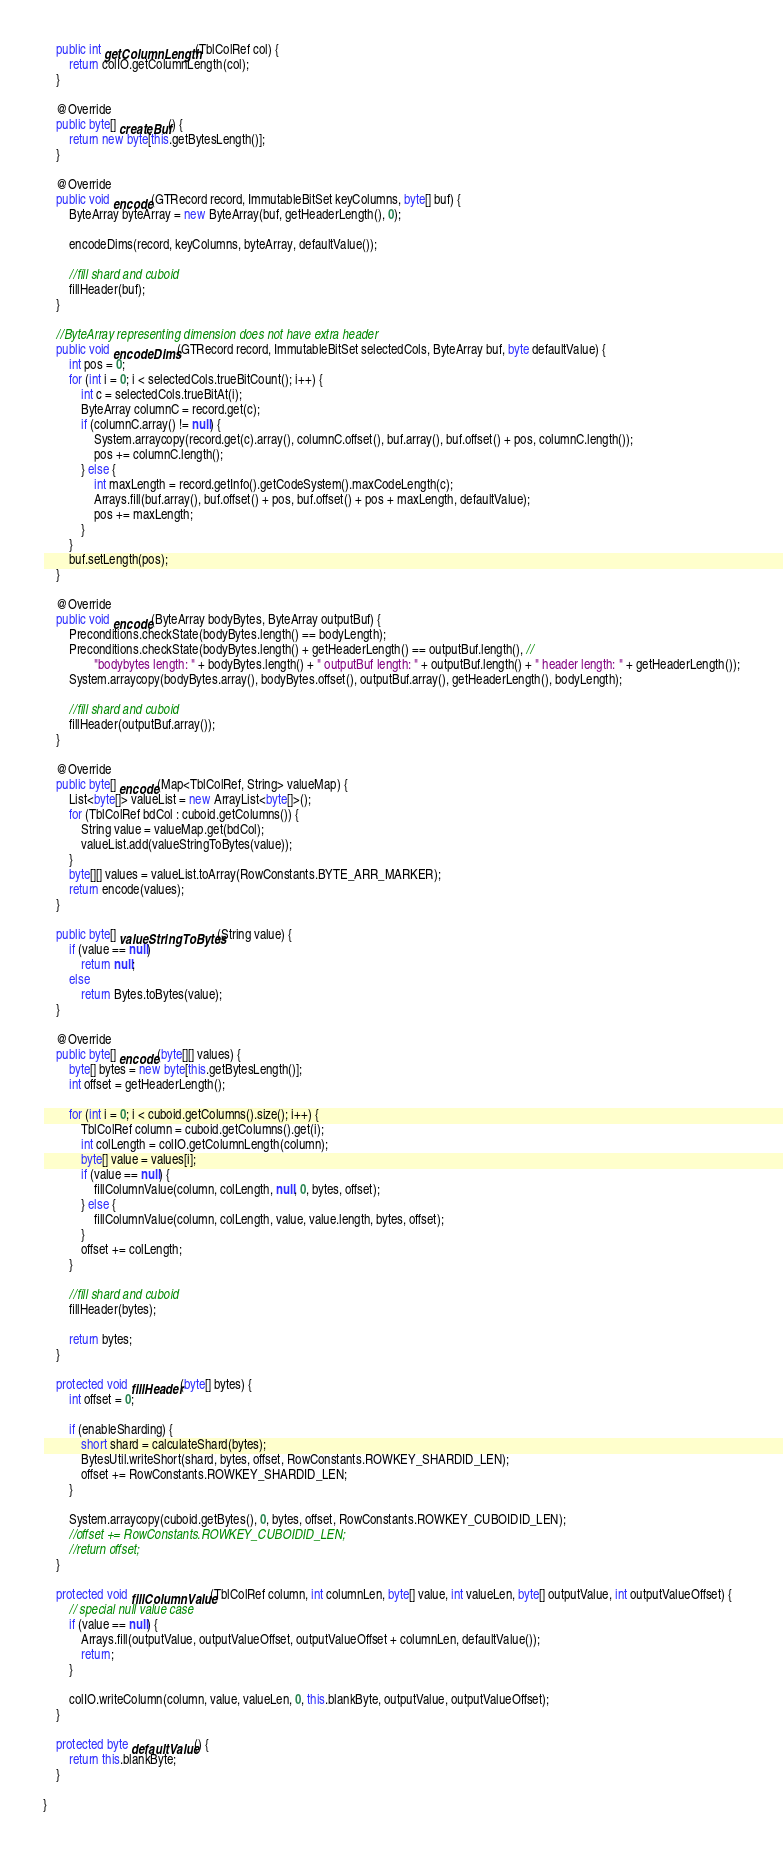<code> <loc_0><loc_0><loc_500><loc_500><_Java_>    public int getColumnLength(TblColRef col) {
        return colIO.getColumnLength(col);
    }

    @Override
    public byte[] createBuf() {
        return new byte[this.getBytesLength()];
    }

    @Override
    public void encode(GTRecord record, ImmutableBitSet keyColumns, byte[] buf) {
        ByteArray byteArray = new ByteArray(buf, getHeaderLength(), 0);

        encodeDims(record, keyColumns, byteArray, defaultValue());

        //fill shard and cuboid
        fillHeader(buf);
    }

    //ByteArray representing dimension does not have extra header
    public void encodeDims(GTRecord record, ImmutableBitSet selectedCols, ByteArray buf, byte defaultValue) {
        int pos = 0;
        for (int i = 0; i < selectedCols.trueBitCount(); i++) {
            int c = selectedCols.trueBitAt(i);
            ByteArray columnC = record.get(c);
            if (columnC.array() != null) {
                System.arraycopy(record.get(c).array(), columnC.offset(), buf.array(), buf.offset() + pos, columnC.length());
                pos += columnC.length();
            } else {
                int maxLength = record.getInfo().getCodeSystem().maxCodeLength(c);
                Arrays.fill(buf.array(), buf.offset() + pos, buf.offset() + pos + maxLength, defaultValue);
                pos += maxLength;
            }
        }
        buf.setLength(pos);
    }

    @Override
    public void encode(ByteArray bodyBytes, ByteArray outputBuf) {
        Preconditions.checkState(bodyBytes.length() == bodyLength);
        Preconditions.checkState(bodyBytes.length() + getHeaderLength() == outputBuf.length(), //
                "bodybytes length: " + bodyBytes.length() + " outputBuf length: " + outputBuf.length() + " header length: " + getHeaderLength());
        System.arraycopy(bodyBytes.array(), bodyBytes.offset(), outputBuf.array(), getHeaderLength(), bodyLength);

        //fill shard and cuboid
        fillHeader(outputBuf.array());
    }

    @Override
    public byte[] encode(Map<TblColRef, String> valueMap) {
        List<byte[]> valueList = new ArrayList<byte[]>();
        for (TblColRef bdCol : cuboid.getColumns()) {
            String value = valueMap.get(bdCol);
            valueList.add(valueStringToBytes(value));
        }
        byte[][] values = valueList.toArray(RowConstants.BYTE_ARR_MARKER);
        return encode(values);
    }

    public byte[] valueStringToBytes(String value) {
        if (value == null)
            return null;
        else
            return Bytes.toBytes(value);
    }

    @Override
    public byte[] encode(byte[][] values) {
        byte[] bytes = new byte[this.getBytesLength()];
        int offset = getHeaderLength();

        for (int i = 0; i < cuboid.getColumns().size(); i++) {
            TblColRef column = cuboid.getColumns().get(i);
            int colLength = colIO.getColumnLength(column);
            byte[] value = values[i];
            if (value == null) {
                fillColumnValue(column, colLength, null, 0, bytes, offset);
            } else {
                fillColumnValue(column, colLength, value, value.length, bytes, offset);
            }
            offset += colLength;
        }

        //fill shard and cuboid
        fillHeader(bytes);

        return bytes;
    }

    protected void fillHeader(byte[] bytes) {
        int offset = 0;

        if (enableSharding) {
            short shard = calculateShard(bytes);
            BytesUtil.writeShort(shard, bytes, offset, RowConstants.ROWKEY_SHARDID_LEN);
            offset += RowConstants.ROWKEY_SHARDID_LEN;
        }

        System.arraycopy(cuboid.getBytes(), 0, bytes, offset, RowConstants.ROWKEY_CUBOIDID_LEN);
        //offset += RowConstants.ROWKEY_CUBOIDID_LEN;
        //return offset;
    }

    protected void fillColumnValue(TblColRef column, int columnLen, byte[] value, int valueLen, byte[] outputValue, int outputValueOffset) {
        // special null value case
        if (value == null) {
            Arrays.fill(outputValue, outputValueOffset, outputValueOffset + columnLen, defaultValue());
            return;
        }

        colIO.writeColumn(column, value, valueLen, 0, this.blankByte, outputValue, outputValueOffset);
    }

    protected byte defaultValue() {
        return this.blankByte;
    }

}
</code> 